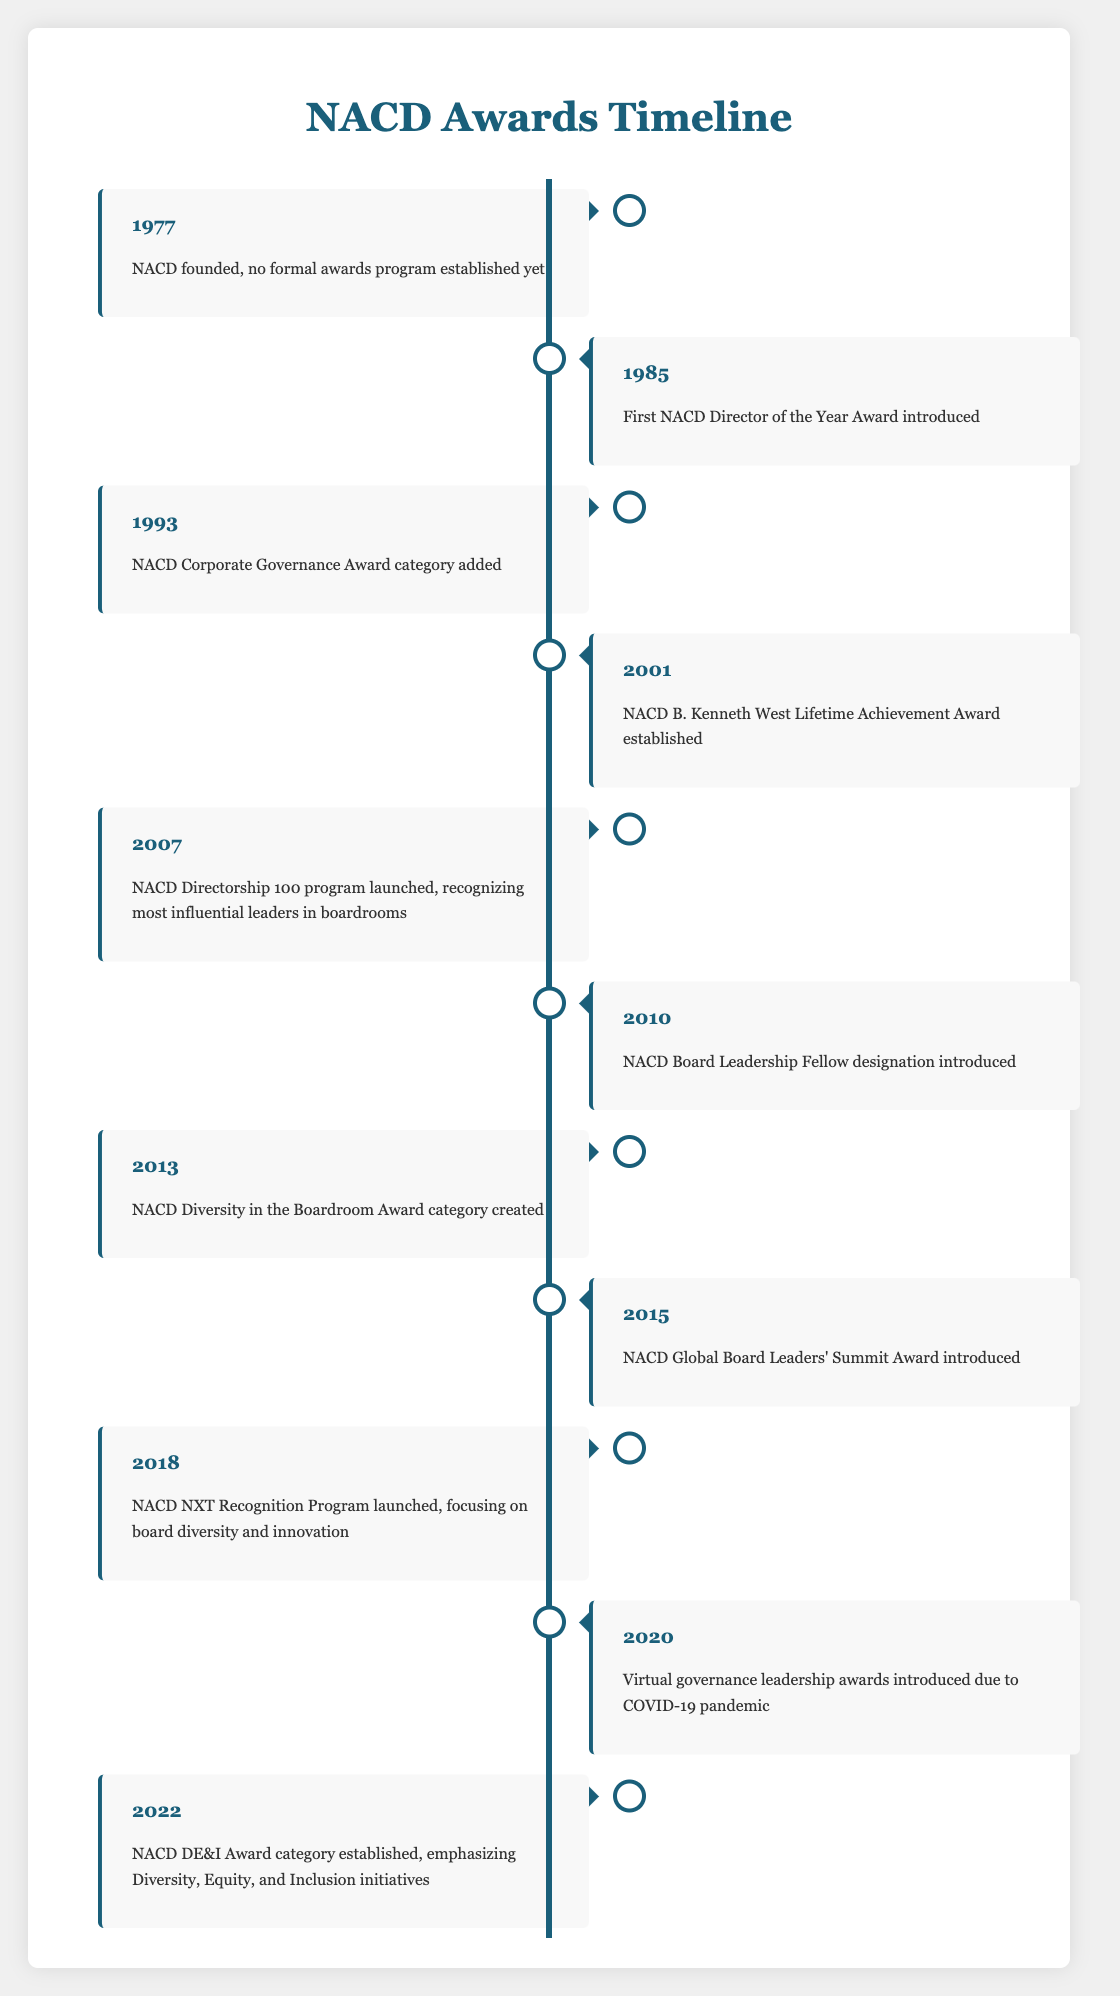What year was the NACD founded? The timeline shows that NACD was founded in 1977 and mentions "no formal awards program established yet."
Answer: 1977 What award was introduced in 1985? According to the timeline, the first NACD Director of the Year Award was introduced in 1985.
Answer: First NACD Director of the Year Award How many awards were established between 2001 and 2015? Reviewing the timeline, the awards established between 2001 and 2015 are: NACD B. Kenneth West Lifetime Achievement Award (2001), NACD Directorship 100 program (2007), NACD Board Leadership Fellow (2010), NACD Diversity in the Boardroom Award (2013), and NACD Global Board Leaders' Summit Award (2015). This totals to five awards.
Answer: 5 Was the NACD DE&I Award introduced before or after the NACD NXT Recognition Program? The timeline shows that the NACD NXT Recognition Program was launched in 2018 and the NACD DE&I Award was established in 2022. Therefore, the DE&I Award was introduced after the NXT Recognition Program.
Answer: After How many years elapsed between the establishment of the first award and the creation of the Diversity in the Boardroom Award? The first award, the NACD Director of the Year Award, was introduced in 1985 and the Diversity in the Boardroom Award was created in 2013. To find the elapsed time, calculate 2013 - 1985, which equals 28 years.
Answer: 28 years Which award category was added in 1993? The timeline indicates that the NACD Corporate Governance Award category was added in 1993.
Answer: NACD Corporate Governance Award Did the introduction of the virtual governance leadership awards occur in a year with a significant global event? The timeline states that the virtual governance leadership awards were introduced in 2020, which aligns with the COVID-19 pandemic—a significant global event.
Answer: Yes Can you list all the awards introduced in the 2010s? In reviewing the timeline for the 2010s, the awards introduced include: NACD Board Leadership Fellow (2010), NACD Diversity in the Boardroom Award (2013), NACD Global Board Leaders' Summit Award (2015), and NACD NXT Recognition Program (2018). This totals four awards.
Answer: 4 awards What is the newest award category mentioned in the timeline? The NACD DE&I Award category, established in 2022, is the most recent award category mentioned in the timeline.
Answer: NACD DE&I Award 